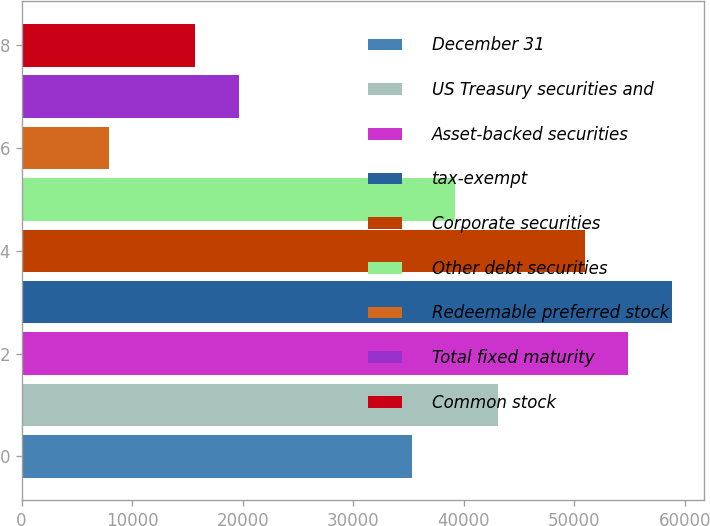<chart> <loc_0><loc_0><loc_500><loc_500><bar_chart><fcel>December 31<fcel>US Treasury securities and<fcel>Asset-backed securities<fcel>tax-exempt<fcel>Corporate securities<fcel>Other debt securities<fcel>Redeemable preferred stock<fcel>Total fixed maturity<fcel>Common stock<nl><fcel>35311.5<fcel>43150.5<fcel>54909<fcel>58828.5<fcel>50989.5<fcel>39231<fcel>7875<fcel>19633.5<fcel>15714<nl></chart> 